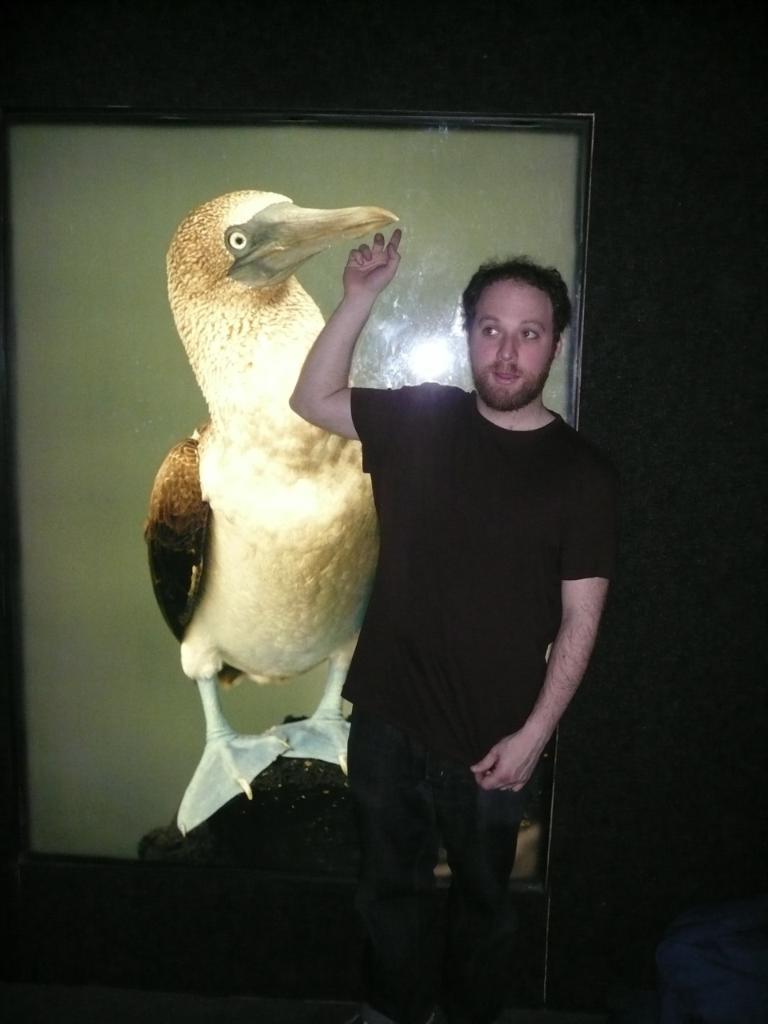Could you give a brief overview of what you see in this image? In this image in the front there is a man standing and having some expression on his face. In the background there is a drawing of a bird on the frame. 